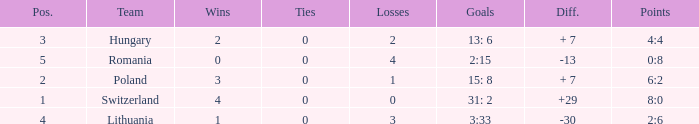Which team had fewer than 2 losses and a position number more than 1? Poland. 